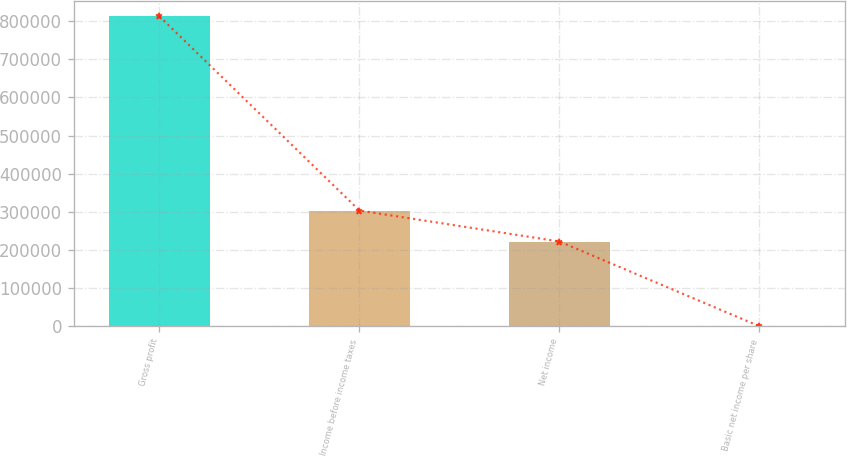Convert chart to OTSL. <chart><loc_0><loc_0><loc_500><loc_500><bar_chart><fcel>Gross profit<fcel>Income before income taxes<fcel>Net income<fcel>Basic net income per share<nl><fcel>812615<fcel>303469<fcel>222208<fcel>0.39<nl></chart> 